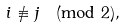<formula> <loc_0><loc_0><loc_500><loc_500>i \not \equiv j \pmod { 2 } ,</formula> 